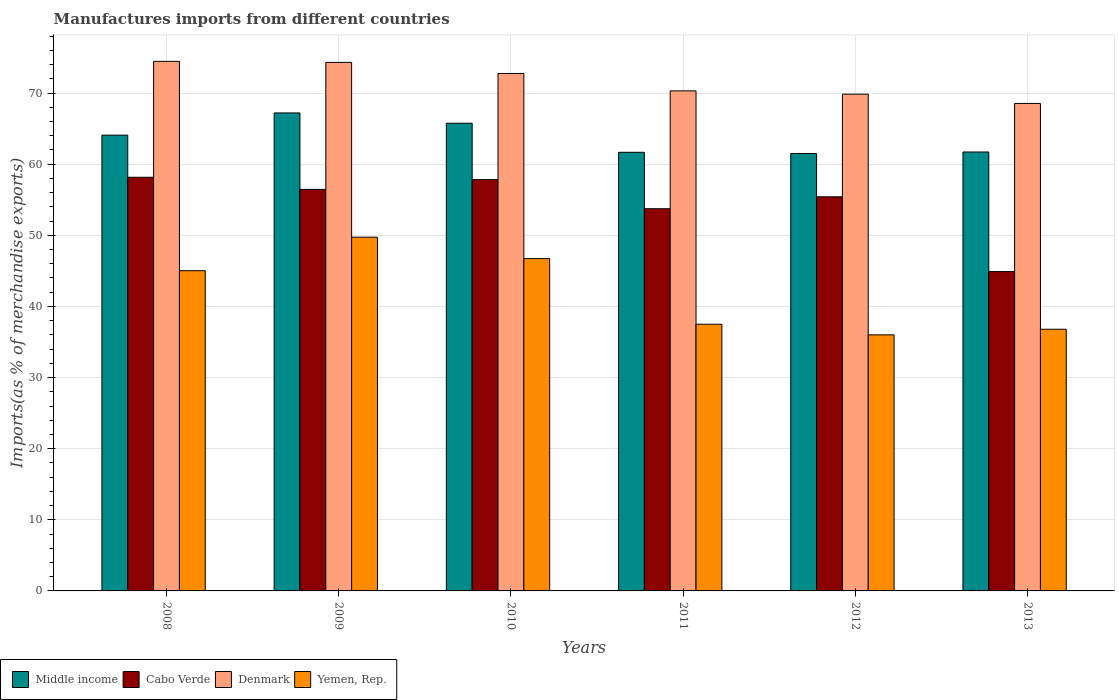How many groups of bars are there?
Offer a very short reply. 6. Are the number of bars per tick equal to the number of legend labels?
Keep it short and to the point. Yes. How many bars are there on the 3rd tick from the left?
Provide a succinct answer. 4. What is the percentage of imports to different countries in Yemen, Rep. in 2012?
Give a very brief answer. 36. Across all years, what is the maximum percentage of imports to different countries in Cabo Verde?
Ensure brevity in your answer.  58.16. Across all years, what is the minimum percentage of imports to different countries in Denmark?
Your response must be concise. 68.54. In which year was the percentage of imports to different countries in Middle income maximum?
Provide a short and direct response. 2009. In which year was the percentage of imports to different countries in Cabo Verde minimum?
Provide a short and direct response. 2013. What is the total percentage of imports to different countries in Denmark in the graph?
Make the answer very short. 430.24. What is the difference between the percentage of imports to different countries in Yemen, Rep. in 2010 and that in 2013?
Give a very brief answer. 9.94. What is the difference between the percentage of imports to different countries in Middle income in 2008 and the percentage of imports to different countries in Denmark in 2009?
Your answer should be very brief. -10.23. What is the average percentage of imports to different countries in Cabo Verde per year?
Provide a short and direct response. 54.42. In the year 2013, what is the difference between the percentage of imports to different countries in Middle income and percentage of imports to different countries in Yemen, Rep.?
Ensure brevity in your answer.  24.92. What is the ratio of the percentage of imports to different countries in Cabo Verde in 2009 to that in 2010?
Keep it short and to the point. 0.98. What is the difference between the highest and the second highest percentage of imports to different countries in Yemen, Rep.?
Provide a succinct answer. 3.01. What is the difference between the highest and the lowest percentage of imports to different countries in Yemen, Rep.?
Keep it short and to the point. 13.73. Is the sum of the percentage of imports to different countries in Denmark in 2011 and 2013 greater than the maximum percentage of imports to different countries in Yemen, Rep. across all years?
Provide a succinct answer. Yes. Is it the case that in every year, the sum of the percentage of imports to different countries in Middle income and percentage of imports to different countries in Cabo Verde is greater than the percentage of imports to different countries in Denmark?
Your answer should be compact. Yes. Are all the bars in the graph horizontal?
Provide a succinct answer. No. How many years are there in the graph?
Offer a terse response. 6. Does the graph contain any zero values?
Your response must be concise. No. Does the graph contain grids?
Your answer should be very brief. Yes. How many legend labels are there?
Offer a terse response. 4. What is the title of the graph?
Your response must be concise. Manufactures imports from different countries. What is the label or title of the Y-axis?
Provide a succinct answer. Imports(as % of merchandise exports). What is the Imports(as % of merchandise exports) of Middle income in 2008?
Ensure brevity in your answer.  64.09. What is the Imports(as % of merchandise exports) of Cabo Verde in 2008?
Keep it short and to the point. 58.16. What is the Imports(as % of merchandise exports) in Denmark in 2008?
Give a very brief answer. 74.46. What is the Imports(as % of merchandise exports) in Yemen, Rep. in 2008?
Provide a succinct answer. 45.03. What is the Imports(as % of merchandise exports) in Middle income in 2009?
Your response must be concise. 67.21. What is the Imports(as % of merchandise exports) in Cabo Verde in 2009?
Offer a terse response. 56.46. What is the Imports(as % of merchandise exports) in Denmark in 2009?
Your answer should be very brief. 74.32. What is the Imports(as % of merchandise exports) of Yemen, Rep. in 2009?
Keep it short and to the point. 49.73. What is the Imports(as % of merchandise exports) in Middle income in 2010?
Your answer should be very brief. 65.76. What is the Imports(as % of merchandise exports) in Cabo Verde in 2010?
Your response must be concise. 57.83. What is the Imports(as % of merchandise exports) in Denmark in 2010?
Make the answer very short. 72.76. What is the Imports(as % of merchandise exports) in Yemen, Rep. in 2010?
Make the answer very short. 46.73. What is the Imports(as % of merchandise exports) of Middle income in 2011?
Offer a terse response. 61.67. What is the Imports(as % of merchandise exports) in Cabo Verde in 2011?
Give a very brief answer. 53.74. What is the Imports(as % of merchandise exports) of Denmark in 2011?
Give a very brief answer. 70.31. What is the Imports(as % of merchandise exports) in Yemen, Rep. in 2011?
Keep it short and to the point. 37.5. What is the Imports(as % of merchandise exports) in Middle income in 2012?
Provide a succinct answer. 61.5. What is the Imports(as % of merchandise exports) in Cabo Verde in 2012?
Your answer should be very brief. 55.41. What is the Imports(as % of merchandise exports) of Denmark in 2012?
Ensure brevity in your answer.  69.85. What is the Imports(as % of merchandise exports) of Yemen, Rep. in 2012?
Offer a terse response. 36. What is the Imports(as % of merchandise exports) of Middle income in 2013?
Keep it short and to the point. 61.72. What is the Imports(as % of merchandise exports) in Cabo Verde in 2013?
Give a very brief answer. 44.9. What is the Imports(as % of merchandise exports) in Denmark in 2013?
Keep it short and to the point. 68.54. What is the Imports(as % of merchandise exports) in Yemen, Rep. in 2013?
Your response must be concise. 36.79. Across all years, what is the maximum Imports(as % of merchandise exports) in Middle income?
Your answer should be very brief. 67.21. Across all years, what is the maximum Imports(as % of merchandise exports) in Cabo Verde?
Provide a succinct answer. 58.16. Across all years, what is the maximum Imports(as % of merchandise exports) of Denmark?
Give a very brief answer. 74.46. Across all years, what is the maximum Imports(as % of merchandise exports) in Yemen, Rep.?
Provide a succinct answer. 49.73. Across all years, what is the minimum Imports(as % of merchandise exports) in Middle income?
Make the answer very short. 61.5. Across all years, what is the minimum Imports(as % of merchandise exports) of Cabo Verde?
Your response must be concise. 44.9. Across all years, what is the minimum Imports(as % of merchandise exports) in Denmark?
Provide a short and direct response. 68.54. Across all years, what is the minimum Imports(as % of merchandise exports) of Yemen, Rep.?
Ensure brevity in your answer.  36. What is the total Imports(as % of merchandise exports) in Middle income in the graph?
Your response must be concise. 381.94. What is the total Imports(as % of merchandise exports) in Cabo Verde in the graph?
Offer a terse response. 326.5. What is the total Imports(as % of merchandise exports) in Denmark in the graph?
Provide a succinct answer. 430.24. What is the total Imports(as % of merchandise exports) of Yemen, Rep. in the graph?
Make the answer very short. 251.78. What is the difference between the Imports(as % of merchandise exports) in Middle income in 2008 and that in 2009?
Offer a very short reply. -3.12. What is the difference between the Imports(as % of merchandise exports) in Cabo Verde in 2008 and that in 2009?
Ensure brevity in your answer.  1.7. What is the difference between the Imports(as % of merchandise exports) of Denmark in 2008 and that in 2009?
Offer a very short reply. 0.14. What is the difference between the Imports(as % of merchandise exports) of Yemen, Rep. in 2008 and that in 2009?
Your answer should be compact. -4.71. What is the difference between the Imports(as % of merchandise exports) of Middle income in 2008 and that in 2010?
Provide a succinct answer. -1.67. What is the difference between the Imports(as % of merchandise exports) in Cabo Verde in 2008 and that in 2010?
Your answer should be very brief. 0.33. What is the difference between the Imports(as % of merchandise exports) in Denmark in 2008 and that in 2010?
Offer a terse response. 1.7. What is the difference between the Imports(as % of merchandise exports) in Yemen, Rep. in 2008 and that in 2010?
Give a very brief answer. -1.7. What is the difference between the Imports(as % of merchandise exports) of Middle income in 2008 and that in 2011?
Your answer should be compact. 2.41. What is the difference between the Imports(as % of merchandise exports) of Cabo Verde in 2008 and that in 2011?
Your answer should be compact. 4.42. What is the difference between the Imports(as % of merchandise exports) of Denmark in 2008 and that in 2011?
Give a very brief answer. 4.15. What is the difference between the Imports(as % of merchandise exports) in Yemen, Rep. in 2008 and that in 2011?
Provide a succinct answer. 7.53. What is the difference between the Imports(as % of merchandise exports) of Middle income in 2008 and that in 2012?
Provide a succinct answer. 2.59. What is the difference between the Imports(as % of merchandise exports) in Cabo Verde in 2008 and that in 2012?
Make the answer very short. 2.75. What is the difference between the Imports(as % of merchandise exports) in Denmark in 2008 and that in 2012?
Your response must be concise. 4.61. What is the difference between the Imports(as % of merchandise exports) of Yemen, Rep. in 2008 and that in 2012?
Give a very brief answer. 9.02. What is the difference between the Imports(as % of merchandise exports) in Middle income in 2008 and that in 2013?
Offer a terse response. 2.37. What is the difference between the Imports(as % of merchandise exports) of Cabo Verde in 2008 and that in 2013?
Provide a short and direct response. 13.26. What is the difference between the Imports(as % of merchandise exports) of Denmark in 2008 and that in 2013?
Ensure brevity in your answer.  5.92. What is the difference between the Imports(as % of merchandise exports) in Yemen, Rep. in 2008 and that in 2013?
Provide a succinct answer. 8.23. What is the difference between the Imports(as % of merchandise exports) of Middle income in 2009 and that in 2010?
Offer a terse response. 1.45. What is the difference between the Imports(as % of merchandise exports) in Cabo Verde in 2009 and that in 2010?
Your answer should be compact. -1.38. What is the difference between the Imports(as % of merchandise exports) in Denmark in 2009 and that in 2010?
Your answer should be very brief. 1.56. What is the difference between the Imports(as % of merchandise exports) in Yemen, Rep. in 2009 and that in 2010?
Your answer should be compact. 3.01. What is the difference between the Imports(as % of merchandise exports) in Middle income in 2009 and that in 2011?
Offer a terse response. 5.53. What is the difference between the Imports(as % of merchandise exports) in Cabo Verde in 2009 and that in 2011?
Ensure brevity in your answer.  2.72. What is the difference between the Imports(as % of merchandise exports) in Denmark in 2009 and that in 2011?
Provide a succinct answer. 4.01. What is the difference between the Imports(as % of merchandise exports) of Yemen, Rep. in 2009 and that in 2011?
Your answer should be compact. 12.23. What is the difference between the Imports(as % of merchandise exports) of Middle income in 2009 and that in 2012?
Make the answer very short. 5.71. What is the difference between the Imports(as % of merchandise exports) in Cabo Verde in 2009 and that in 2012?
Ensure brevity in your answer.  1.04. What is the difference between the Imports(as % of merchandise exports) of Denmark in 2009 and that in 2012?
Your answer should be compact. 4.47. What is the difference between the Imports(as % of merchandise exports) in Yemen, Rep. in 2009 and that in 2012?
Offer a very short reply. 13.73. What is the difference between the Imports(as % of merchandise exports) of Middle income in 2009 and that in 2013?
Your response must be concise. 5.49. What is the difference between the Imports(as % of merchandise exports) in Cabo Verde in 2009 and that in 2013?
Your response must be concise. 11.55. What is the difference between the Imports(as % of merchandise exports) of Denmark in 2009 and that in 2013?
Your answer should be compact. 5.77. What is the difference between the Imports(as % of merchandise exports) of Yemen, Rep. in 2009 and that in 2013?
Your answer should be very brief. 12.94. What is the difference between the Imports(as % of merchandise exports) of Middle income in 2010 and that in 2011?
Give a very brief answer. 4.09. What is the difference between the Imports(as % of merchandise exports) in Cabo Verde in 2010 and that in 2011?
Provide a succinct answer. 4.09. What is the difference between the Imports(as % of merchandise exports) of Denmark in 2010 and that in 2011?
Provide a succinct answer. 2.45. What is the difference between the Imports(as % of merchandise exports) of Yemen, Rep. in 2010 and that in 2011?
Provide a short and direct response. 9.23. What is the difference between the Imports(as % of merchandise exports) of Middle income in 2010 and that in 2012?
Offer a terse response. 4.26. What is the difference between the Imports(as % of merchandise exports) in Cabo Verde in 2010 and that in 2012?
Provide a short and direct response. 2.42. What is the difference between the Imports(as % of merchandise exports) of Denmark in 2010 and that in 2012?
Ensure brevity in your answer.  2.91. What is the difference between the Imports(as % of merchandise exports) in Yemen, Rep. in 2010 and that in 2012?
Provide a succinct answer. 10.72. What is the difference between the Imports(as % of merchandise exports) of Middle income in 2010 and that in 2013?
Your response must be concise. 4.04. What is the difference between the Imports(as % of merchandise exports) in Cabo Verde in 2010 and that in 2013?
Ensure brevity in your answer.  12.93. What is the difference between the Imports(as % of merchandise exports) in Denmark in 2010 and that in 2013?
Your answer should be very brief. 4.22. What is the difference between the Imports(as % of merchandise exports) of Yemen, Rep. in 2010 and that in 2013?
Your answer should be very brief. 9.94. What is the difference between the Imports(as % of merchandise exports) in Middle income in 2011 and that in 2012?
Your answer should be very brief. 0.17. What is the difference between the Imports(as % of merchandise exports) in Cabo Verde in 2011 and that in 2012?
Provide a succinct answer. -1.68. What is the difference between the Imports(as % of merchandise exports) of Denmark in 2011 and that in 2012?
Give a very brief answer. 0.46. What is the difference between the Imports(as % of merchandise exports) of Yemen, Rep. in 2011 and that in 2012?
Give a very brief answer. 1.5. What is the difference between the Imports(as % of merchandise exports) of Middle income in 2011 and that in 2013?
Your answer should be very brief. -0.04. What is the difference between the Imports(as % of merchandise exports) in Cabo Verde in 2011 and that in 2013?
Keep it short and to the point. 8.83. What is the difference between the Imports(as % of merchandise exports) of Denmark in 2011 and that in 2013?
Your response must be concise. 1.77. What is the difference between the Imports(as % of merchandise exports) of Yemen, Rep. in 2011 and that in 2013?
Provide a short and direct response. 0.71. What is the difference between the Imports(as % of merchandise exports) of Middle income in 2012 and that in 2013?
Your response must be concise. -0.22. What is the difference between the Imports(as % of merchandise exports) in Cabo Verde in 2012 and that in 2013?
Your response must be concise. 10.51. What is the difference between the Imports(as % of merchandise exports) of Denmark in 2012 and that in 2013?
Offer a very short reply. 1.31. What is the difference between the Imports(as % of merchandise exports) of Yemen, Rep. in 2012 and that in 2013?
Provide a succinct answer. -0.79. What is the difference between the Imports(as % of merchandise exports) in Middle income in 2008 and the Imports(as % of merchandise exports) in Cabo Verde in 2009?
Offer a very short reply. 7.63. What is the difference between the Imports(as % of merchandise exports) in Middle income in 2008 and the Imports(as % of merchandise exports) in Denmark in 2009?
Your answer should be very brief. -10.23. What is the difference between the Imports(as % of merchandise exports) in Middle income in 2008 and the Imports(as % of merchandise exports) in Yemen, Rep. in 2009?
Give a very brief answer. 14.35. What is the difference between the Imports(as % of merchandise exports) in Cabo Verde in 2008 and the Imports(as % of merchandise exports) in Denmark in 2009?
Your answer should be compact. -16.16. What is the difference between the Imports(as % of merchandise exports) in Cabo Verde in 2008 and the Imports(as % of merchandise exports) in Yemen, Rep. in 2009?
Your answer should be compact. 8.43. What is the difference between the Imports(as % of merchandise exports) of Denmark in 2008 and the Imports(as % of merchandise exports) of Yemen, Rep. in 2009?
Your answer should be compact. 24.73. What is the difference between the Imports(as % of merchandise exports) of Middle income in 2008 and the Imports(as % of merchandise exports) of Cabo Verde in 2010?
Your response must be concise. 6.26. What is the difference between the Imports(as % of merchandise exports) in Middle income in 2008 and the Imports(as % of merchandise exports) in Denmark in 2010?
Make the answer very short. -8.67. What is the difference between the Imports(as % of merchandise exports) of Middle income in 2008 and the Imports(as % of merchandise exports) of Yemen, Rep. in 2010?
Offer a very short reply. 17.36. What is the difference between the Imports(as % of merchandise exports) in Cabo Verde in 2008 and the Imports(as % of merchandise exports) in Denmark in 2010?
Ensure brevity in your answer.  -14.6. What is the difference between the Imports(as % of merchandise exports) in Cabo Verde in 2008 and the Imports(as % of merchandise exports) in Yemen, Rep. in 2010?
Your answer should be compact. 11.43. What is the difference between the Imports(as % of merchandise exports) of Denmark in 2008 and the Imports(as % of merchandise exports) of Yemen, Rep. in 2010?
Give a very brief answer. 27.73. What is the difference between the Imports(as % of merchandise exports) in Middle income in 2008 and the Imports(as % of merchandise exports) in Cabo Verde in 2011?
Provide a succinct answer. 10.35. What is the difference between the Imports(as % of merchandise exports) in Middle income in 2008 and the Imports(as % of merchandise exports) in Denmark in 2011?
Offer a terse response. -6.22. What is the difference between the Imports(as % of merchandise exports) in Middle income in 2008 and the Imports(as % of merchandise exports) in Yemen, Rep. in 2011?
Provide a short and direct response. 26.59. What is the difference between the Imports(as % of merchandise exports) of Cabo Verde in 2008 and the Imports(as % of merchandise exports) of Denmark in 2011?
Make the answer very short. -12.15. What is the difference between the Imports(as % of merchandise exports) in Cabo Verde in 2008 and the Imports(as % of merchandise exports) in Yemen, Rep. in 2011?
Provide a succinct answer. 20.66. What is the difference between the Imports(as % of merchandise exports) of Denmark in 2008 and the Imports(as % of merchandise exports) of Yemen, Rep. in 2011?
Your response must be concise. 36.96. What is the difference between the Imports(as % of merchandise exports) in Middle income in 2008 and the Imports(as % of merchandise exports) in Cabo Verde in 2012?
Keep it short and to the point. 8.67. What is the difference between the Imports(as % of merchandise exports) of Middle income in 2008 and the Imports(as % of merchandise exports) of Denmark in 2012?
Offer a terse response. -5.76. What is the difference between the Imports(as % of merchandise exports) in Middle income in 2008 and the Imports(as % of merchandise exports) in Yemen, Rep. in 2012?
Offer a very short reply. 28.08. What is the difference between the Imports(as % of merchandise exports) in Cabo Verde in 2008 and the Imports(as % of merchandise exports) in Denmark in 2012?
Offer a terse response. -11.69. What is the difference between the Imports(as % of merchandise exports) in Cabo Verde in 2008 and the Imports(as % of merchandise exports) in Yemen, Rep. in 2012?
Keep it short and to the point. 22.16. What is the difference between the Imports(as % of merchandise exports) of Denmark in 2008 and the Imports(as % of merchandise exports) of Yemen, Rep. in 2012?
Provide a succinct answer. 38.46. What is the difference between the Imports(as % of merchandise exports) of Middle income in 2008 and the Imports(as % of merchandise exports) of Cabo Verde in 2013?
Ensure brevity in your answer.  19.18. What is the difference between the Imports(as % of merchandise exports) in Middle income in 2008 and the Imports(as % of merchandise exports) in Denmark in 2013?
Your answer should be very brief. -4.46. What is the difference between the Imports(as % of merchandise exports) of Middle income in 2008 and the Imports(as % of merchandise exports) of Yemen, Rep. in 2013?
Ensure brevity in your answer.  27.29. What is the difference between the Imports(as % of merchandise exports) of Cabo Verde in 2008 and the Imports(as % of merchandise exports) of Denmark in 2013?
Keep it short and to the point. -10.38. What is the difference between the Imports(as % of merchandise exports) of Cabo Verde in 2008 and the Imports(as % of merchandise exports) of Yemen, Rep. in 2013?
Offer a very short reply. 21.37. What is the difference between the Imports(as % of merchandise exports) of Denmark in 2008 and the Imports(as % of merchandise exports) of Yemen, Rep. in 2013?
Your response must be concise. 37.67. What is the difference between the Imports(as % of merchandise exports) of Middle income in 2009 and the Imports(as % of merchandise exports) of Cabo Verde in 2010?
Ensure brevity in your answer.  9.37. What is the difference between the Imports(as % of merchandise exports) in Middle income in 2009 and the Imports(as % of merchandise exports) in Denmark in 2010?
Give a very brief answer. -5.55. What is the difference between the Imports(as % of merchandise exports) in Middle income in 2009 and the Imports(as % of merchandise exports) in Yemen, Rep. in 2010?
Your response must be concise. 20.48. What is the difference between the Imports(as % of merchandise exports) of Cabo Verde in 2009 and the Imports(as % of merchandise exports) of Denmark in 2010?
Your answer should be compact. -16.3. What is the difference between the Imports(as % of merchandise exports) in Cabo Verde in 2009 and the Imports(as % of merchandise exports) in Yemen, Rep. in 2010?
Your response must be concise. 9.73. What is the difference between the Imports(as % of merchandise exports) in Denmark in 2009 and the Imports(as % of merchandise exports) in Yemen, Rep. in 2010?
Keep it short and to the point. 27.59. What is the difference between the Imports(as % of merchandise exports) of Middle income in 2009 and the Imports(as % of merchandise exports) of Cabo Verde in 2011?
Provide a succinct answer. 13.47. What is the difference between the Imports(as % of merchandise exports) of Middle income in 2009 and the Imports(as % of merchandise exports) of Denmark in 2011?
Provide a short and direct response. -3.1. What is the difference between the Imports(as % of merchandise exports) in Middle income in 2009 and the Imports(as % of merchandise exports) in Yemen, Rep. in 2011?
Your response must be concise. 29.71. What is the difference between the Imports(as % of merchandise exports) in Cabo Verde in 2009 and the Imports(as % of merchandise exports) in Denmark in 2011?
Offer a very short reply. -13.85. What is the difference between the Imports(as % of merchandise exports) in Cabo Verde in 2009 and the Imports(as % of merchandise exports) in Yemen, Rep. in 2011?
Ensure brevity in your answer.  18.96. What is the difference between the Imports(as % of merchandise exports) of Denmark in 2009 and the Imports(as % of merchandise exports) of Yemen, Rep. in 2011?
Your answer should be very brief. 36.82. What is the difference between the Imports(as % of merchandise exports) in Middle income in 2009 and the Imports(as % of merchandise exports) in Cabo Verde in 2012?
Offer a terse response. 11.79. What is the difference between the Imports(as % of merchandise exports) in Middle income in 2009 and the Imports(as % of merchandise exports) in Denmark in 2012?
Provide a short and direct response. -2.64. What is the difference between the Imports(as % of merchandise exports) in Middle income in 2009 and the Imports(as % of merchandise exports) in Yemen, Rep. in 2012?
Provide a short and direct response. 31.2. What is the difference between the Imports(as % of merchandise exports) in Cabo Verde in 2009 and the Imports(as % of merchandise exports) in Denmark in 2012?
Your answer should be compact. -13.39. What is the difference between the Imports(as % of merchandise exports) in Cabo Verde in 2009 and the Imports(as % of merchandise exports) in Yemen, Rep. in 2012?
Your answer should be very brief. 20.45. What is the difference between the Imports(as % of merchandise exports) in Denmark in 2009 and the Imports(as % of merchandise exports) in Yemen, Rep. in 2012?
Provide a short and direct response. 38.31. What is the difference between the Imports(as % of merchandise exports) in Middle income in 2009 and the Imports(as % of merchandise exports) in Cabo Verde in 2013?
Keep it short and to the point. 22.3. What is the difference between the Imports(as % of merchandise exports) in Middle income in 2009 and the Imports(as % of merchandise exports) in Denmark in 2013?
Your response must be concise. -1.34. What is the difference between the Imports(as % of merchandise exports) of Middle income in 2009 and the Imports(as % of merchandise exports) of Yemen, Rep. in 2013?
Your answer should be compact. 30.41. What is the difference between the Imports(as % of merchandise exports) in Cabo Verde in 2009 and the Imports(as % of merchandise exports) in Denmark in 2013?
Provide a succinct answer. -12.09. What is the difference between the Imports(as % of merchandise exports) in Cabo Verde in 2009 and the Imports(as % of merchandise exports) in Yemen, Rep. in 2013?
Offer a terse response. 19.66. What is the difference between the Imports(as % of merchandise exports) in Denmark in 2009 and the Imports(as % of merchandise exports) in Yemen, Rep. in 2013?
Your answer should be very brief. 37.52. What is the difference between the Imports(as % of merchandise exports) of Middle income in 2010 and the Imports(as % of merchandise exports) of Cabo Verde in 2011?
Your answer should be very brief. 12.02. What is the difference between the Imports(as % of merchandise exports) in Middle income in 2010 and the Imports(as % of merchandise exports) in Denmark in 2011?
Ensure brevity in your answer.  -4.55. What is the difference between the Imports(as % of merchandise exports) of Middle income in 2010 and the Imports(as % of merchandise exports) of Yemen, Rep. in 2011?
Your response must be concise. 28.26. What is the difference between the Imports(as % of merchandise exports) in Cabo Verde in 2010 and the Imports(as % of merchandise exports) in Denmark in 2011?
Ensure brevity in your answer.  -12.48. What is the difference between the Imports(as % of merchandise exports) of Cabo Verde in 2010 and the Imports(as % of merchandise exports) of Yemen, Rep. in 2011?
Provide a short and direct response. 20.33. What is the difference between the Imports(as % of merchandise exports) in Denmark in 2010 and the Imports(as % of merchandise exports) in Yemen, Rep. in 2011?
Provide a short and direct response. 35.26. What is the difference between the Imports(as % of merchandise exports) in Middle income in 2010 and the Imports(as % of merchandise exports) in Cabo Verde in 2012?
Keep it short and to the point. 10.35. What is the difference between the Imports(as % of merchandise exports) of Middle income in 2010 and the Imports(as % of merchandise exports) of Denmark in 2012?
Your answer should be very brief. -4.09. What is the difference between the Imports(as % of merchandise exports) of Middle income in 2010 and the Imports(as % of merchandise exports) of Yemen, Rep. in 2012?
Give a very brief answer. 29.75. What is the difference between the Imports(as % of merchandise exports) in Cabo Verde in 2010 and the Imports(as % of merchandise exports) in Denmark in 2012?
Offer a very short reply. -12.02. What is the difference between the Imports(as % of merchandise exports) in Cabo Verde in 2010 and the Imports(as % of merchandise exports) in Yemen, Rep. in 2012?
Your response must be concise. 21.83. What is the difference between the Imports(as % of merchandise exports) in Denmark in 2010 and the Imports(as % of merchandise exports) in Yemen, Rep. in 2012?
Make the answer very short. 36.75. What is the difference between the Imports(as % of merchandise exports) of Middle income in 2010 and the Imports(as % of merchandise exports) of Cabo Verde in 2013?
Provide a succinct answer. 20.86. What is the difference between the Imports(as % of merchandise exports) in Middle income in 2010 and the Imports(as % of merchandise exports) in Denmark in 2013?
Ensure brevity in your answer.  -2.78. What is the difference between the Imports(as % of merchandise exports) in Middle income in 2010 and the Imports(as % of merchandise exports) in Yemen, Rep. in 2013?
Your answer should be very brief. 28.97. What is the difference between the Imports(as % of merchandise exports) in Cabo Verde in 2010 and the Imports(as % of merchandise exports) in Denmark in 2013?
Offer a very short reply. -10.71. What is the difference between the Imports(as % of merchandise exports) in Cabo Verde in 2010 and the Imports(as % of merchandise exports) in Yemen, Rep. in 2013?
Offer a terse response. 21.04. What is the difference between the Imports(as % of merchandise exports) of Denmark in 2010 and the Imports(as % of merchandise exports) of Yemen, Rep. in 2013?
Ensure brevity in your answer.  35.97. What is the difference between the Imports(as % of merchandise exports) in Middle income in 2011 and the Imports(as % of merchandise exports) in Cabo Verde in 2012?
Provide a succinct answer. 6.26. What is the difference between the Imports(as % of merchandise exports) in Middle income in 2011 and the Imports(as % of merchandise exports) in Denmark in 2012?
Keep it short and to the point. -8.18. What is the difference between the Imports(as % of merchandise exports) in Middle income in 2011 and the Imports(as % of merchandise exports) in Yemen, Rep. in 2012?
Provide a succinct answer. 25.67. What is the difference between the Imports(as % of merchandise exports) of Cabo Verde in 2011 and the Imports(as % of merchandise exports) of Denmark in 2012?
Provide a short and direct response. -16.11. What is the difference between the Imports(as % of merchandise exports) in Cabo Verde in 2011 and the Imports(as % of merchandise exports) in Yemen, Rep. in 2012?
Provide a short and direct response. 17.73. What is the difference between the Imports(as % of merchandise exports) in Denmark in 2011 and the Imports(as % of merchandise exports) in Yemen, Rep. in 2012?
Your answer should be compact. 34.31. What is the difference between the Imports(as % of merchandise exports) in Middle income in 2011 and the Imports(as % of merchandise exports) in Cabo Verde in 2013?
Your answer should be very brief. 16.77. What is the difference between the Imports(as % of merchandise exports) of Middle income in 2011 and the Imports(as % of merchandise exports) of Denmark in 2013?
Keep it short and to the point. -6.87. What is the difference between the Imports(as % of merchandise exports) in Middle income in 2011 and the Imports(as % of merchandise exports) in Yemen, Rep. in 2013?
Keep it short and to the point. 24.88. What is the difference between the Imports(as % of merchandise exports) of Cabo Verde in 2011 and the Imports(as % of merchandise exports) of Denmark in 2013?
Offer a very short reply. -14.8. What is the difference between the Imports(as % of merchandise exports) of Cabo Verde in 2011 and the Imports(as % of merchandise exports) of Yemen, Rep. in 2013?
Ensure brevity in your answer.  16.95. What is the difference between the Imports(as % of merchandise exports) in Denmark in 2011 and the Imports(as % of merchandise exports) in Yemen, Rep. in 2013?
Ensure brevity in your answer.  33.52. What is the difference between the Imports(as % of merchandise exports) of Middle income in 2012 and the Imports(as % of merchandise exports) of Cabo Verde in 2013?
Your response must be concise. 16.59. What is the difference between the Imports(as % of merchandise exports) of Middle income in 2012 and the Imports(as % of merchandise exports) of Denmark in 2013?
Offer a very short reply. -7.04. What is the difference between the Imports(as % of merchandise exports) of Middle income in 2012 and the Imports(as % of merchandise exports) of Yemen, Rep. in 2013?
Your answer should be compact. 24.71. What is the difference between the Imports(as % of merchandise exports) in Cabo Verde in 2012 and the Imports(as % of merchandise exports) in Denmark in 2013?
Provide a succinct answer. -13.13. What is the difference between the Imports(as % of merchandise exports) in Cabo Verde in 2012 and the Imports(as % of merchandise exports) in Yemen, Rep. in 2013?
Your response must be concise. 18.62. What is the difference between the Imports(as % of merchandise exports) in Denmark in 2012 and the Imports(as % of merchandise exports) in Yemen, Rep. in 2013?
Keep it short and to the point. 33.06. What is the average Imports(as % of merchandise exports) in Middle income per year?
Keep it short and to the point. 63.66. What is the average Imports(as % of merchandise exports) in Cabo Verde per year?
Provide a succinct answer. 54.42. What is the average Imports(as % of merchandise exports) in Denmark per year?
Provide a succinct answer. 71.71. What is the average Imports(as % of merchandise exports) in Yemen, Rep. per year?
Ensure brevity in your answer.  41.96. In the year 2008, what is the difference between the Imports(as % of merchandise exports) in Middle income and Imports(as % of merchandise exports) in Cabo Verde?
Keep it short and to the point. 5.93. In the year 2008, what is the difference between the Imports(as % of merchandise exports) in Middle income and Imports(as % of merchandise exports) in Denmark?
Offer a very short reply. -10.37. In the year 2008, what is the difference between the Imports(as % of merchandise exports) of Middle income and Imports(as % of merchandise exports) of Yemen, Rep.?
Keep it short and to the point. 19.06. In the year 2008, what is the difference between the Imports(as % of merchandise exports) of Cabo Verde and Imports(as % of merchandise exports) of Denmark?
Give a very brief answer. -16.3. In the year 2008, what is the difference between the Imports(as % of merchandise exports) of Cabo Verde and Imports(as % of merchandise exports) of Yemen, Rep.?
Keep it short and to the point. 13.14. In the year 2008, what is the difference between the Imports(as % of merchandise exports) in Denmark and Imports(as % of merchandise exports) in Yemen, Rep.?
Offer a terse response. 29.43. In the year 2009, what is the difference between the Imports(as % of merchandise exports) in Middle income and Imports(as % of merchandise exports) in Cabo Verde?
Ensure brevity in your answer.  10.75. In the year 2009, what is the difference between the Imports(as % of merchandise exports) in Middle income and Imports(as % of merchandise exports) in Denmark?
Make the answer very short. -7.11. In the year 2009, what is the difference between the Imports(as % of merchandise exports) of Middle income and Imports(as % of merchandise exports) of Yemen, Rep.?
Keep it short and to the point. 17.47. In the year 2009, what is the difference between the Imports(as % of merchandise exports) in Cabo Verde and Imports(as % of merchandise exports) in Denmark?
Provide a succinct answer. -17.86. In the year 2009, what is the difference between the Imports(as % of merchandise exports) of Cabo Verde and Imports(as % of merchandise exports) of Yemen, Rep.?
Your answer should be compact. 6.72. In the year 2009, what is the difference between the Imports(as % of merchandise exports) in Denmark and Imports(as % of merchandise exports) in Yemen, Rep.?
Give a very brief answer. 24.58. In the year 2010, what is the difference between the Imports(as % of merchandise exports) of Middle income and Imports(as % of merchandise exports) of Cabo Verde?
Keep it short and to the point. 7.93. In the year 2010, what is the difference between the Imports(as % of merchandise exports) of Middle income and Imports(as % of merchandise exports) of Denmark?
Your response must be concise. -7. In the year 2010, what is the difference between the Imports(as % of merchandise exports) of Middle income and Imports(as % of merchandise exports) of Yemen, Rep.?
Your response must be concise. 19.03. In the year 2010, what is the difference between the Imports(as % of merchandise exports) of Cabo Verde and Imports(as % of merchandise exports) of Denmark?
Provide a short and direct response. -14.93. In the year 2010, what is the difference between the Imports(as % of merchandise exports) of Cabo Verde and Imports(as % of merchandise exports) of Yemen, Rep.?
Offer a very short reply. 11.1. In the year 2010, what is the difference between the Imports(as % of merchandise exports) of Denmark and Imports(as % of merchandise exports) of Yemen, Rep.?
Offer a terse response. 26.03. In the year 2011, what is the difference between the Imports(as % of merchandise exports) of Middle income and Imports(as % of merchandise exports) of Cabo Verde?
Ensure brevity in your answer.  7.93. In the year 2011, what is the difference between the Imports(as % of merchandise exports) in Middle income and Imports(as % of merchandise exports) in Denmark?
Your response must be concise. -8.64. In the year 2011, what is the difference between the Imports(as % of merchandise exports) of Middle income and Imports(as % of merchandise exports) of Yemen, Rep.?
Ensure brevity in your answer.  24.17. In the year 2011, what is the difference between the Imports(as % of merchandise exports) of Cabo Verde and Imports(as % of merchandise exports) of Denmark?
Keep it short and to the point. -16.57. In the year 2011, what is the difference between the Imports(as % of merchandise exports) in Cabo Verde and Imports(as % of merchandise exports) in Yemen, Rep.?
Offer a terse response. 16.24. In the year 2011, what is the difference between the Imports(as % of merchandise exports) of Denmark and Imports(as % of merchandise exports) of Yemen, Rep.?
Provide a short and direct response. 32.81. In the year 2012, what is the difference between the Imports(as % of merchandise exports) in Middle income and Imports(as % of merchandise exports) in Cabo Verde?
Your response must be concise. 6.08. In the year 2012, what is the difference between the Imports(as % of merchandise exports) in Middle income and Imports(as % of merchandise exports) in Denmark?
Offer a very short reply. -8.35. In the year 2012, what is the difference between the Imports(as % of merchandise exports) in Middle income and Imports(as % of merchandise exports) in Yemen, Rep.?
Offer a terse response. 25.49. In the year 2012, what is the difference between the Imports(as % of merchandise exports) in Cabo Verde and Imports(as % of merchandise exports) in Denmark?
Your answer should be compact. -14.44. In the year 2012, what is the difference between the Imports(as % of merchandise exports) of Cabo Verde and Imports(as % of merchandise exports) of Yemen, Rep.?
Ensure brevity in your answer.  19.41. In the year 2012, what is the difference between the Imports(as % of merchandise exports) in Denmark and Imports(as % of merchandise exports) in Yemen, Rep.?
Ensure brevity in your answer.  33.85. In the year 2013, what is the difference between the Imports(as % of merchandise exports) of Middle income and Imports(as % of merchandise exports) of Cabo Verde?
Your response must be concise. 16.81. In the year 2013, what is the difference between the Imports(as % of merchandise exports) of Middle income and Imports(as % of merchandise exports) of Denmark?
Your response must be concise. -6.83. In the year 2013, what is the difference between the Imports(as % of merchandise exports) of Middle income and Imports(as % of merchandise exports) of Yemen, Rep.?
Ensure brevity in your answer.  24.92. In the year 2013, what is the difference between the Imports(as % of merchandise exports) of Cabo Verde and Imports(as % of merchandise exports) of Denmark?
Make the answer very short. -23.64. In the year 2013, what is the difference between the Imports(as % of merchandise exports) in Cabo Verde and Imports(as % of merchandise exports) in Yemen, Rep.?
Ensure brevity in your answer.  8.11. In the year 2013, what is the difference between the Imports(as % of merchandise exports) of Denmark and Imports(as % of merchandise exports) of Yemen, Rep.?
Offer a terse response. 31.75. What is the ratio of the Imports(as % of merchandise exports) in Middle income in 2008 to that in 2009?
Make the answer very short. 0.95. What is the ratio of the Imports(as % of merchandise exports) of Cabo Verde in 2008 to that in 2009?
Provide a short and direct response. 1.03. What is the ratio of the Imports(as % of merchandise exports) of Yemen, Rep. in 2008 to that in 2009?
Your response must be concise. 0.91. What is the ratio of the Imports(as % of merchandise exports) in Middle income in 2008 to that in 2010?
Ensure brevity in your answer.  0.97. What is the ratio of the Imports(as % of merchandise exports) of Cabo Verde in 2008 to that in 2010?
Your answer should be compact. 1.01. What is the ratio of the Imports(as % of merchandise exports) in Denmark in 2008 to that in 2010?
Make the answer very short. 1.02. What is the ratio of the Imports(as % of merchandise exports) of Yemen, Rep. in 2008 to that in 2010?
Offer a terse response. 0.96. What is the ratio of the Imports(as % of merchandise exports) of Middle income in 2008 to that in 2011?
Your answer should be compact. 1.04. What is the ratio of the Imports(as % of merchandise exports) in Cabo Verde in 2008 to that in 2011?
Make the answer very short. 1.08. What is the ratio of the Imports(as % of merchandise exports) of Denmark in 2008 to that in 2011?
Make the answer very short. 1.06. What is the ratio of the Imports(as % of merchandise exports) in Yemen, Rep. in 2008 to that in 2011?
Provide a succinct answer. 1.2. What is the ratio of the Imports(as % of merchandise exports) in Middle income in 2008 to that in 2012?
Provide a short and direct response. 1.04. What is the ratio of the Imports(as % of merchandise exports) of Cabo Verde in 2008 to that in 2012?
Make the answer very short. 1.05. What is the ratio of the Imports(as % of merchandise exports) in Denmark in 2008 to that in 2012?
Keep it short and to the point. 1.07. What is the ratio of the Imports(as % of merchandise exports) of Yemen, Rep. in 2008 to that in 2012?
Provide a short and direct response. 1.25. What is the ratio of the Imports(as % of merchandise exports) in Middle income in 2008 to that in 2013?
Ensure brevity in your answer.  1.04. What is the ratio of the Imports(as % of merchandise exports) of Cabo Verde in 2008 to that in 2013?
Offer a terse response. 1.3. What is the ratio of the Imports(as % of merchandise exports) in Denmark in 2008 to that in 2013?
Offer a very short reply. 1.09. What is the ratio of the Imports(as % of merchandise exports) in Yemen, Rep. in 2008 to that in 2013?
Make the answer very short. 1.22. What is the ratio of the Imports(as % of merchandise exports) of Middle income in 2009 to that in 2010?
Provide a short and direct response. 1.02. What is the ratio of the Imports(as % of merchandise exports) in Cabo Verde in 2009 to that in 2010?
Give a very brief answer. 0.98. What is the ratio of the Imports(as % of merchandise exports) in Denmark in 2009 to that in 2010?
Ensure brevity in your answer.  1.02. What is the ratio of the Imports(as % of merchandise exports) of Yemen, Rep. in 2009 to that in 2010?
Offer a very short reply. 1.06. What is the ratio of the Imports(as % of merchandise exports) of Middle income in 2009 to that in 2011?
Make the answer very short. 1.09. What is the ratio of the Imports(as % of merchandise exports) of Cabo Verde in 2009 to that in 2011?
Make the answer very short. 1.05. What is the ratio of the Imports(as % of merchandise exports) of Denmark in 2009 to that in 2011?
Your response must be concise. 1.06. What is the ratio of the Imports(as % of merchandise exports) of Yemen, Rep. in 2009 to that in 2011?
Provide a short and direct response. 1.33. What is the ratio of the Imports(as % of merchandise exports) in Middle income in 2009 to that in 2012?
Your response must be concise. 1.09. What is the ratio of the Imports(as % of merchandise exports) of Cabo Verde in 2009 to that in 2012?
Your answer should be very brief. 1.02. What is the ratio of the Imports(as % of merchandise exports) of Denmark in 2009 to that in 2012?
Provide a short and direct response. 1.06. What is the ratio of the Imports(as % of merchandise exports) of Yemen, Rep. in 2009 to that in 2012?
Your answer should be very brief. 1.38. What is the ratio of the Imports(as % of merchandise exports) in Middle income in 2009 to that in 2013?
Your answer should be compact. 1.09. What is the ratio of the Imports(as % of merchandise exports) of Cabo Verde in 2009 to that in 2013?
Your response must be concise. 1.26. What is the ratio of the Imports(as % of merchandise exports) of Denmark in 2009 to that in 2013?
Your response must be concise. 1.08. What is the ratio of the Imports(as % of merchandise exports) of Yemen, Rep. in 2009 to that in 2013?
Your response must be concise. 1.35. What is the ratio of the Imports(as % of merchandise exports) of Middle income in 2010 to that in 2011?
Keep it short and to the point. 1.07. What is the ratio of the Imports(as % of merchandise exports) in Cabo Verde in 2010 to that in 2011?
Your answer should be compact. 1.08. What is the ratio of the Imports(as % of merchandise exports) of Denmark in 2010 to that in 2011?
Ensure brevity in your answer.  1.03. What is the ratio of the Imports(as % of merchandise exports) of Yemen, Rep. in 2010 to that in 2011?
Give a very brief answer. 1.25. What is the ratio of the Imports(as % of merchandise exports) in Middle income in 2010 to that in 2012?
Make the answer very short. 1.07. What is the ratio of the Imports(as % of merchandise exports) of Cabo Verde in 2010 to that in 2012?
Make the answer very short. 1.04. What is the ratio of the Imports(as % of merchandise exports) of Denmark in 2010 to that in 2012?
Offer a very short reply. 1.04. What is the ratio of the Imports(as % of merchandise exports) of Yemen, Rep. in 2010 to that in 2012?
Offer a very short reply. 1.3. What is the ratio of the Imports(as % of merchandise exports) of Middle income in 2010 to that in 2013?
Give a very brief answer. 1.07. What is the ratio of the Imports(as % of merchandise exports) of Cabo Verde in 2010 to that in 2013?
Your answer should be very brief. 1.29. What is the ratio of the Imports(as % of merchandise exports) in Denmark in 2010 to that in 2013?
Your response must be concise. 1.06. What is the ratio of the Imports(as % of merchandise exports) in Yemen, Rep. in 2010 to that in 2013?
Keep it short and to the point. 1.27. What is the ratio of the Imports(as % of merchandise exports) in Middle income in 2011 to that in 2012?
Give a very brief answer. 1. What is the ratio of the Imports(as % of merchandise exports) of Cabo Verde in 2011 to that in 2012?
Ensure brevity in your answer.  0.97. What is the ratio of the Imports(as % of merchandise exports) in Denmark in 2011 to that in 2012?
Provide a short and direct response. 1.01. What is the ratio of the Imports(as % of merchandise exports) of Yemen, Rep. in 2011 to that in 2012?
Provide a short and direct response. 1.04. What is the ratio of the Imports(as % of merchandise exports) of Cabo Verde in 2011 to that in 2013?
Offer a very short reply. 1.2. What is the ratio of the Imports(as % of merchandise exports) of Denmark in 2011 to that in 2013?
Provide a succinct answer. 1.03. What is the ratio of the Imports(as % of merchandise exports) of Yemen, Rep. in 2011 to that in 2013?
Provide a short and direct response. 1.02. What is the ratio of the Imports(as % of merchandise exports) of Middle income in 2012 to that in 2013?
Your answer should be compact. 1. What is the ratio of the Imports(as % of merchandise exports) in Cabo Verde in 2012 to that in 2013?
Keep it short and to the point. 1.23. What is the ratio of the Imports(as % of merchandise exports) in Denmark in 2012 to that in 2013?
Your response must be concise. 1.02. What is the ratio of the Imports(as % of merchandise exports) in Yemen, Rep. in 2012 to that in 2013?
Provide a succinct answer. 0.98. What is the difference between the highest and the second highest Imports(as % of merchandise exports) in Middle income?
Offer a very short reply. 1.45. What is the difference between the highest and the second highest Imports(as % of merchandise exports) of Cabo Verde?
Make the answer very short. 0.33. What is the difference between the highest and the second highest Imports(as % of merchandise exports) in Denmark?
Offer a terse response. 0.14. What is the difference between the highest and the second highest Imports(as % of merchandise exports) of Yemen, Rep.?
Ensure brevity in your answer.  3.01. What is the difference between the highest and the lowest Imports(as % of merchandise exports) of Middle income?
Give a very brief answer. 5.71. What is the difference between the highest and the lowest Imports(as % of merchandise exports) of Cabo Verde?
Offer a very short reply. 13.26. What is the difference between the highest and the lowest Imports(as % of merchandise exports) of Denmark?
Provide a succinct answer. 5.92. What is the difference between the highest and the lowest Imports(as % of merchandise exports) of Yemen, Rep.?
Your answer should be very brief. 13.73. 